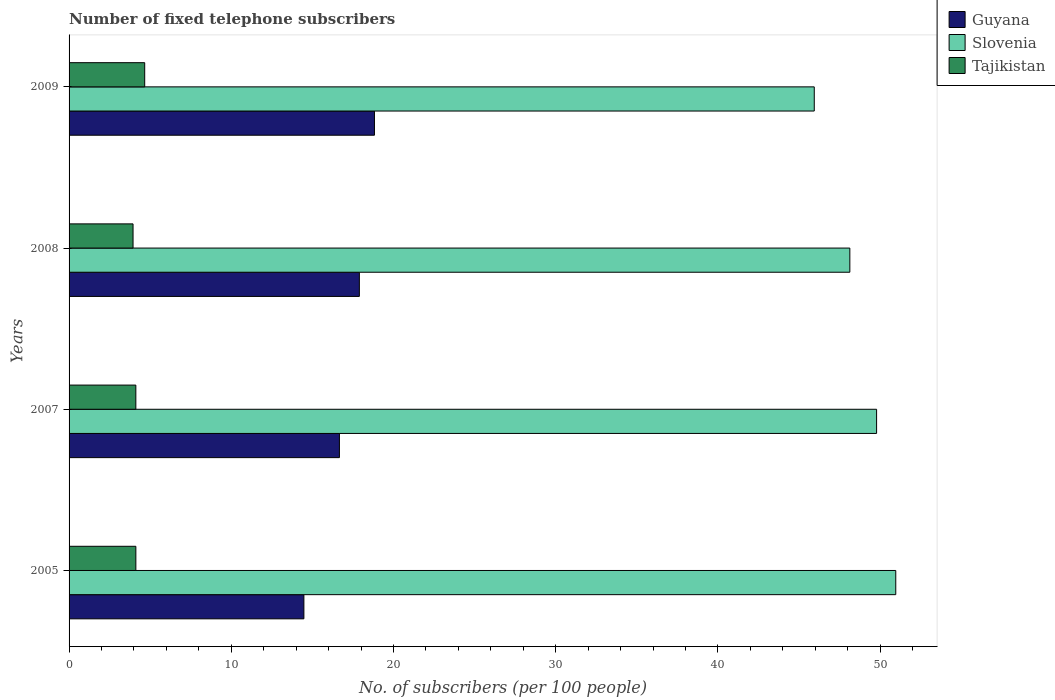What is the number of fixed telephone subscribers in Guyana in 2005?
Provide a succinct answer. 14.48. Across all years, what is the maximum number of fixed telephone subscribers in Tajikistan?
Your response must be concise. 4.66. Across all years, what is the minimum number of fixed telephone subscribers in Guyana?
Offer a terse response. 14.48. In which year was the number of fixed telephone subscribers in Tajikistan maximum?
Provide a succinct answer. 2009. What is the total number of fixed telephone subscribers in Slovenia in the graph?
Provide a short and direct response. 194.81. What is the difference between the number of fixed telephone subscribers in Guyana in 2007 and that in 2008?
Offer a very short reply. -1.23. What is the difference between the number of fixed telephone subscribers in Slovenia in 2008 and the number of fixed telephone subscribers in Guyana in 2007?
Give a very brief answer. 31.47. What is the average number of fixed telephone subscribers in Guyana per year?
Ensure brevity in your answer.  16.97. In the year 2009, what is the difference between the number of fixed telephone subscribers in Slovenia and number of fixed telephone subscribers in Tajikistan?
Give a very brief answer. 41.28. In how many years, is the number of fixed telephone subscribers in Slovenia greater than 4 ?
Keep it short and to the point. 4. What is the ratio of the number of fixed telephone subscribers in Tajikistan in 2007 to that in 2008?
Your answer should be compact. 1.04. Is the difference between the number of fixed telephone subscribers in Slovenia in 2005 and 2008 greater than the difference between the number of fixed telephone subscribers in Tajikistan in 2005 and 2008?
Offer a terse response. Yes. What is the difference between the highest and the second highest number of fixed telephone subscribers in Slovenia?
Make the answer very short. 1.18. What is the difference between the highest and the lowest number of fixed telephone subscribers in Slovenia?
Your response must be concise. 5.02. In how many years, is the number of fixed telephone subscribers in Slovenia greater than the average number of fixed telephone subscribers in Slovenia taken over all years?
Provide a succinct answer. 2. What does the 3rd bar from the top in 2007 represents?
Offer a very short reply. Guyana. What does the 3rd bar from the bottom in 2007 represents?
Offer a very short reply. Tajikistan. Are all the bars in the graph horizontal?
Keep it short and to the point. Yes. What is the difference between two consecutive major ticks on the X-axis?
Your response must be concise. 10. How are the legend labels stacked?
Ensure brevity in your answer.  Vertical. What is the title of the graph?
Keep it short and to the point. Number of fixed telephone subscribers. What is the label or title of the X-axis?
Your response must be concise. No. of subscribers (per 100 people). What is the label or title of the Y-axis?
Ensure brevity in your answer.  Years. What is the No. of subscribers (per 100 people) of Guyana in 2005?
Offer a very short reply. 14.48. What is the No. of subscribers (per 100 people) of Slovenia in 2005?
Your response must be concise. 50.96. What is the No. of subscribers (per 100 people) in Tajikistan in 2005?
Keep it short and to the point. 4.12. What is the No. of subscribers (per 100 people) of Guyana in 2007?
Ensure brevity in your answer.  16.67. What is the No. of subscribers (per 100 people) in Slovenia in 2007?
Provide a short and direct response. 49.78. What is the No. of subscribers (per 100 people) in Tajikistan in 2007?
Your answer should be compact. 4.12. What is the No. of subscribers (per 100 people) in Guyana in 2008?
Your answer should be very brief. 17.9. What is the No. of subscribers (per 100 people) of Slovenia in 2008?
Your answer should be compact. 48.13. What is the No. of subscribers (per 100 people) of Tajikistan in 2008?
Your response must be concise. 3.94. What is the No. of subscribers (per 100 people) in Guyana in 2009?
Offer a terse response. 18.83. What is the No. of subscribers (per 100 people) in Slovenia in 2009?
Your answer should be very brief. 45.94. What is the No. of subscribers (per 100 people) of Tajikistan in 2009?
Provide a short and direct response. 4.66. Across all years, what is the maximum No. of subscribers (per 100 people) in Guyana?
Give a very brief answer. 18.83. Across all years, what is the maximum No. of subscribers (per 100 people) in Slovenia?
Keep it short and to the point. 50.96. Across all years, what is the maximum No. of subscribers (per 100 people) of Tajikistan?
Offer a very short reply. 4.66. Across all years, what is the minimum No. of subscribers (per 100 people) in Guyana?
Provide a short and direct response. 14.48. Across all years, what is the minimum No. of subscribers (per 100 people) of Slovenia?
Provide a succinct answer. 45.94. Across all years, what is the minimum No. of subscribers (per 100 people) in Tajikistan?
Provide a short and direct response. 3.94. What is the total No. of subscribers (per 100 people) of Guyana in the graph?
Ensure brevity in your answer.  67.86. What is the total No. of subscribers (per 100 people) in Slovenia in the graph?
Your answer should be compact. 194.81. What is the total No. of subscribers (per 100 people) of Tajikistan in the graph?
Your answer should be compact. 16.84. What is the difference between the No. of subscribers (per 100 people) in Guyana in 2005 and that in 2007?
Offer a very short reply. -2.19. What is the difference between the No. of subscribers (per 100 people) in Slovenia in 2005 and that in 2007?
Make the answer very short. 1.18. What is the difference between the No. of subscribers (per 100 people) in Tajikistan in 2005 and that in 2007?
Provide a short and direct response. 0. What is the difference between the No. of subscribers (per 100 people) of Guyana in 2005 and that in 2008?
Offer a terse response. -3.42. What is the difference between the No. of subscribers (per 100 people) of Slovenia in 2005 and that in 2008?
Your response must be concise. 2.83. What is the difference between the No. of subscribers (per 100 people) in Tajikistan in 2005 and that in 2008?
Provide a succinct answer. 0.17. What is the difference between the No. of subscribers (per 100 people) of Guyana in 2005 and that in 2009?
Provide a succinct answer. -4.35. What is the difference between the No. of subscribers (per 100 people) of Slovenia in 2005 and that in 2009?
Make the answer very short. 5.02. What is the difference between the No. of subscribers (per 100 people) in Tajikistan in 2005 and that in 2009?
Keep it short and to the point. -0.55. What is the difference between the No. of subscribers (per 100 people) in Guyana in 2007 and that in 2008?
Keep it short and to the point. -1.23. What is the difference between the No. of subscribers (per 100 people) of Slovenia in 2007 and that in 2008?
Ensure brevity in your answer.  1.65. What is the difference between the No. of subscribers (per 100 people) in Tajikistan in 2007 and that in 2008?
Provide a succinct answer. 0.17. What is the difference between the No. of subscribers (per 100 people) in Guyana in 2007 and that in 2009?
Give a very brief answer. -2.16. What is the difference between the No. of subscribers (per 100 people) of Slovenia in 2007 and that in 2009?
Your response must be concise. 3.84. What is the difference between the No. of subscribers (per 100 people) in Tajikistan in 2007 and that in 2009?
Your answer should be compact. -0.55. What is the difference between the No. of subscribers (per 100 people) in Guyana in 2008 and that in 2009?
Your response must be concise. -0.93. What is the difference between the No. of subscribers (per 100 people) in Slovenia in 2008 and that in 2009?
Offer a terse response. 2.19. What is the difference between the No. of subscribers (per 100 people) in Tajikistan in 2008 and that in 2009?
Offer a terse response. -0.72. What is the difference between the No. of subscribers (per 100 people) in Guyana in 2005 and the No. of subscribers (per 100 people) in Slovenia in 2007?
Give a very brief answer. -35.31. What is the difference between the No. of subscribers (per 100 people) in Guyana in 2005 and the No. of subscribers (per 100 people) in Tajikistan in 2007?
Ensure brevity in your answer.  10.36. What is the difference between the No. of subscribers (per 100 people) of Slovenia in 2005 and the No. of subscribers (per 100 people) of Tajikistan in 2007?
Ensure brevity in your answer.  46.85. What is the difference between the No. of subscribers (per 100 people) of Guyana in 2005 and the No. of subscribers (per 100 people) of Slovenia in 2008?
Your answer should be compact. -33.66. What is the difference between the No. of subscribers (per 100 people) in Guyana in 2005 and the No. of subscribers (per 100 people) in Tajikistan in 2008?
Keep it short and to the point. 10.53. What is the difference between the No. of subscribers (per 100 people) in Slovenia in 2005 and the No. of subscribers (per 100 people) in Tajikistan in 2008?
Ensure brevity in your answer.  47.02. What is the difference between the No. of subscribers (per 100 people) in Guyana in 2005 and the No. of subscribers (per 100 people) in Slovenia in 2009?
Provide a succinct answer. -31.46. What is the difference between the No. of subscribers (per 100 people) in Guyana in 2005 and the No. of subscribers (per 100 people) in Tajikistan in 2009?
Provide a succinct answer. 9.81. What is the difference between the No. of subscribers (per 100 people) of Slovenia in 2005 and the No. of subscribers (per 100 people) of Tajikistan in 2009?
Make the answer very short. 46.3. What is the difference between the No. of subscribers (per 100 people) of Guyana in 2007 and the No. of subscribers (per 100 people) of Slovenia in 2008?
Offer a terse response. -31.47. What is the difference between the No. of subscribers (per 100 people) of Guyana in 2007 and the No. of subscribers (per 100 people) of Tajikistan in 2008?
Keep it short and to the point. 12.72. What is the difference between the No. of subscribers (per 100 people) in Slovenia in 2007 and the No. of subscribers (per 100 people) in Tajikistan in 2008?
Provide a succinct answer. 45.84. What is the difference between the No. of subscribers (per 100 people) of Guyana in 2007 and the No. of subscribers (per 100 people) of Slovenia in 2009?
Ensure brevity in your answer.  -29.27. What is the difference between the No. of subscribers (per 100 people) in Guyana in 2007 and the No. of subscribers (per 100 people) in Tajikistan in 2009?
Provide a succinct answer. 12. What is the difference between the No. of subscribers (per 100 people) in Slovenia in 2007 and the No. of subscribers (per 100 people) in Tajikistan in 2009?
Make the answer very short. 45.12. What is the difference between the No. of subscribers (per 100 people) in Guyana in 2008 and the No. of subscribers (per 100 people) in Slovenia in 2009?
Make the answer very short. -28.04. What is the difference between the No. of subscribers (per 100 people) in Guyana in 2008 and the No. of subscribers (per 100 people) in Tajikistan in 2009?
Your response must be concise. 13.23. What is the difference between the No. of subscribers (per 100 people) of Slovenia in 2008 and the No. of subscribers (per 100 people) of Tajikistan in 2009?
Keep it short and to the point. 43.47. What is the average No. of subscribers (per 100 people) of Guyana per year?
Your response must be concise. 16.97. What is the average No. of subscribers (per 100 people) of Slovenia per year?
Make the answer very short. 48.7. What is the average No. of subscribers (per 100 people) of Tajikistan per year?
Provide a short and direct response. 4.21. In the year 2005, what is the difference between the No. of subscribers (per 100 people) in Guyana and No. of subscribers (per 100 people) in Slovenia?
Your response must be concise. -36.49. In the year 2005, what is the difference between the No. of subscribers (per 100 people) of Guyana and No. of subscribers (per 100 people) of Tajikistan?
Your answer should be very brief. 10.36. In the year 2005, what is the difference between the No. of subscribers (per 100 people) of Slovenia and No. of subscribers (per 100 people) of Tajikistan?
Give a very brief answer. 46.85. In the year 2007, what is the difference between the No. of subscribers (per 100 people) in Guyana and No. of subscribers (per 100 people) in Slovenia?
Provide a succinct answer. -33.12. In the year 2007, what is the difference between the No. of subscribers (per 100 people) in Guyana and No. of subscribers (per 100 people) in Tajikistan?
Your response must be concise. 12.55. In the year 2007, what is the difference between the No. of subscribers (per 100 people) in Slovenia and No. of subscribers (per 100 people) in Tajikistan?
Offer a terse response. 45.66. In the year 2008, what is the difference between the No. of subscribers (per 100 people) in Guyana and No. of subscribers (per 100 people) in Slovenia?
Provide a succinct answer. -30.24. In the year 2008, what is the difference between the No. of subscribers (per 100 people) in Guyana and No. of subscribers (per 100 people) in Tajikistan?
Your answer should be compact. 13.95. In the year 2008, what is the difference between the No. of subscribers (per 100 people) in Slovenia and No. of subscribers (per 100 people) in Tajikistan?
Make the answer very short. 44.19. In the year 2009, what is the difference between the No. of subscribers (per 100 people) of Guyana and No. of subscribers (per 100 people) of Slovenia?
Your answer should be compact. -27.11. In the year 2009, what is the difference between the No. of subscribers (per 100 people) of Guyana and No. of subscribers (per 100 people) of Tajikistan?
Make the answer very short. 14.16. In the year 2009, what is the difference between the No. of subscribers (per 100 people) of Slovenia and No. of subscribers (per 100 people) of Tajikistan?
Keep it short and to the point. 41.28. What is the ratio of the No. of subscribers (per 100 people) of Guyana in 2005 to that in 2007?
Offer a terse response. 0.87. What is the ratio of the No. of subscribers (per 100 people) in Slovenia in 2005 to that in 2007?
Keep it short and to the point. 1.02. What is the ratio of the No. of subscribers (per 100 people) in Tajikistan in 2005 to that in 2007?
Offer a terse response. 1. What is the ratio of the No. of subscribers (per 100 people) of Guyana in 2005 to that in 2008?
Offer a very short reply. 0.81. What is the ratio of the No. of subscribers (per 100 people) of Slovenia in 2005 to that in 2008?
Make the answer very short. 1.06. What is the ratio of the No. of subscribers (per 100 people) of Tajikistan in 2005 to that in 2008?
Keep it short and to the point. 1.04. What is the ratio of the No. of subscribers (per 100 people) of Guyana in 2005 to that in 2009?
Your response must be concise. 0.77. What is the ratio of the No. of subscribers (per 100 people) in Slovenia in 2005 to that in 2009?
Your answer should be compact. 1.11. What is the ratio of the No. of subscribers (per 100 people) of Tajikistan in 2005 to that in 2009?
Your answer should be compact. 0.88. What is the ratio of the No. of subscribers (per 100 people) in Guyana in 2007 to that in 2008?
Offer a terse response. 0.93. What is the ratio of the No. of subscribers (per 100 people) in Slovenia in 2007 to that in 2008?
Provide a short and direct response. 1.03. What is the ratio of the No. of subscribers (per 100 people) of Tajikistan in 2007 to that in 2008?
Provide a short and direct response. 1.04. What is the ratio of the No. of subscribers (per 100 people) in Guyana in 2007 to that in 2009?
Provide a short and direct response. 0.89. What is the ratio of the No. of subscribers (per 100 people) in Slovenia in 2007 to that in 2009?
Your answer should be very brief. 1.08. What is the ratio of the No. of subscribers (per 100 people) of Tajikistan in 2007 to that in 2009?
Your response must be concise. 0.88. What is the ratio of the No. of subscribers (per 100 people) of Guyana in 2008 to that in 2009?
Offer a terse response. 0.95. What is the ratio of the No. of subscribers (per 100 people) of Slovenia in 2008 to that in 2009?
Your response must be concise. 1.05. What is the ratio of the No. of subscribers (per 100 people) in Tajikistan in 2008 to that in 2009?
Provide a short and direct response. 0.85. What is the difference between the highest and the second highest No. of subscribers (per 100 people) in Guyana?
Make the answer very short. 0.93. What is the difference between the highest and the second highest No. of subscribers (per 100 people) of Slovenia?
Provide a short and direct response. 1.18. What is the difference between the highest and the second highest No. of subscribers (per 100 people) in Tajikistan?
Offer a terse response. 0.55. What is the difference between the highest and the lowest No. of subscribers (per 100 people) in Guyana?
Offer a very short reply. 4.35. What is the difference between the highest and the lowest No. of subscribers (per 100 people) of Slovenia?
Offer a very short reply. 5.02. What is the difference between the highest and the lowest No. of subscribers (per 100 people) in Tajikistan?
Your response must be concise. 0.72. 